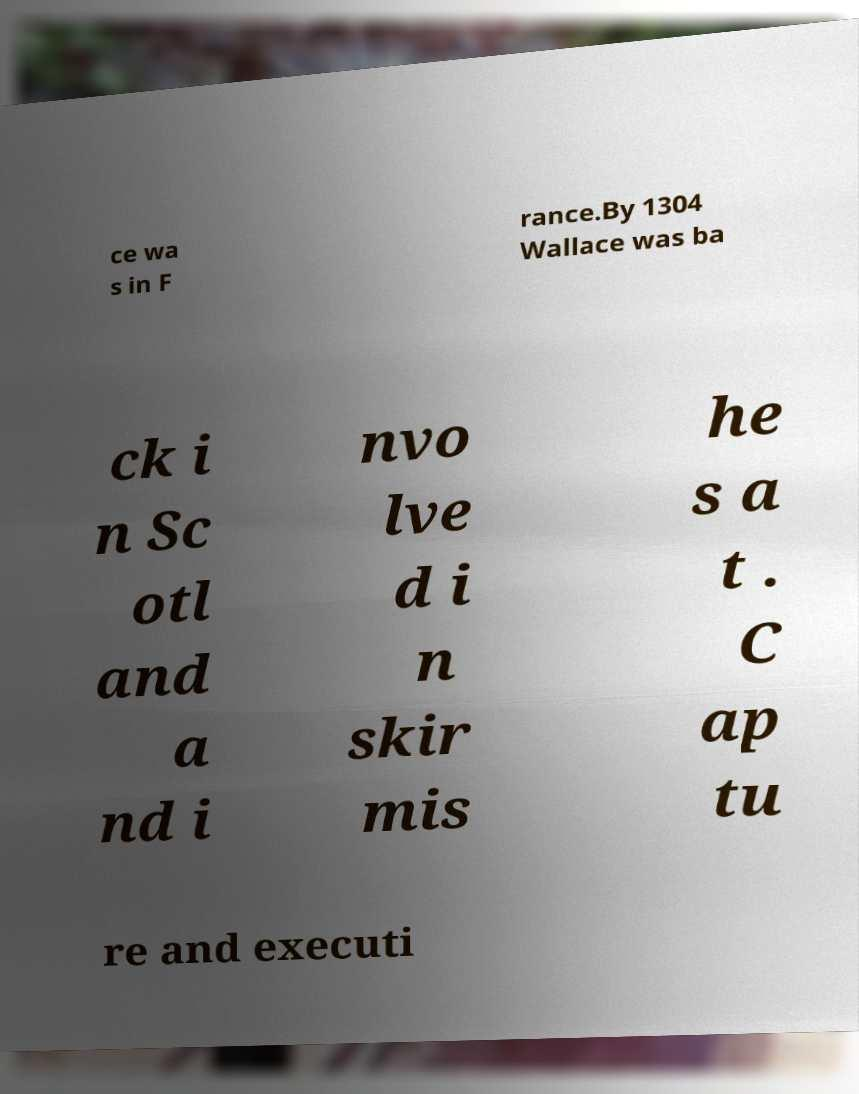Could you extract and type out the text from this image? ce wa s in F rance.By 1304 Wallace was ba ck i n Sc otl and a nd i nvo lve d i n skir mis he s a t . C ap tu re and executi 